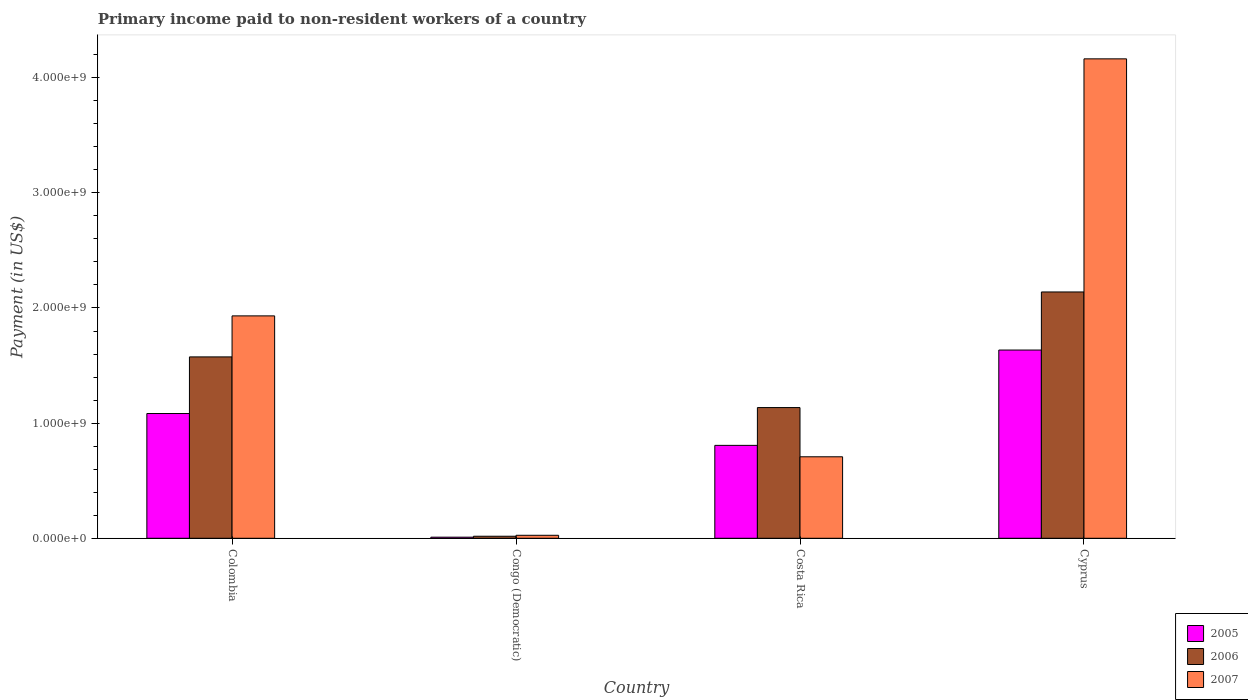How many different coloured bars are there?
Offer a very short reply. 3. How many groups of bars are there?
Provide a short and direct response. 4. How many bars are there on the 2nd tick from the left?
Offer a terse response. 3. How many bars are there on the 4th tick from the right?
Keep it short and to the point. 3. What is the amount paid to workers in 2005 in Costa Rica?
Provide a short and direct response. 8.07e+08. Across all countries, what is the maximum amount paid to workers in 2005?
Make the answer very short. 1.63e+09. Across all countries, what is the minimum amount paid to workers in 2006?
Give a very brief answer. 1.77e+07. In which country was the amount paid to workers in 2006 maximum?
Give a very brief answer. Cyprus. In which country was the amount paid to workers in 2007 minimum?
Your answer should be compact. Congo (Democratic). What is the total amount paid to workers in 2007 in the graph?
Provide a short and direct response. 6.83e+09. What is the difference between the amount paid to workers in 2006 in Colombia and that in Congo (Democratic)?
Your answer should be very brief. 1.56e+09. What is the difference between the amount paid to workers in 2007 in Congo (Democratic) and the amount paid to workers in 2005 in Costa Rica?
Your answer should be very brief. -7.81e+08. What is the average amount paid to workers in 2007 per country?
Make the answer very short. 1.71e+09. What is the difference between the amount paid to workers of/in 2006 and amount paid to workers of/in 2005 in Cyprus?
Your response must be concise. 5.04e+08. What is the ratio of the amount paid to workers in 2006 in Colombia to that in Costa Rica?
Your response must be concise. 1.39. What is the difference between the highest and the second highest amount paid to workers in 2005?
Your answer should be compact. -8.28e+08. What is the difference between the highest and the lowest amount paid to workers in 2005?
Give a very brief answer. 1.63e+09. How many countries are there in the graph?
Ensure brevity in your answer.  4. What is the difference between two consecutive major ticks on the Y-axis?
Offer a terse response. 1.00e+09. Does the graph contain grids?
Give a very brief answer. No. Where does the legend appear in the graph?
Your response must be concise. Bottom right. What is the title of the graph?
Your answer should be very brief. Primary income paid to non-resident workers of a country. What is the label or title of the Y-axis?
Provide a succinct answer. Payment (in US$). What is the Payment (in US$) of 2005 in Colombia?
Provide a succinct answer. 1.08e+09. What is the Payment (in US$) in 2006 in Colombia?
Provide a short and direct response. 1.58e+09. What is the Payment (in US$) of 2007 in Colombia?
Provide a succinct answer. 1.93e+09. What is the Payment (in US$) in 2005 in Congo (Democratic)?
Give a very brief answer. 9.50e+06. What is the Payment (in US$) in 2006 in Congo (Democratic)?
Offer a very short reply. 1.77e+07. What is the Payment (in US$) in 2007 in Congo (Democratic)?
Keep it short and to the point. 2.60e+07. What is the Payment (in US$) in 2005 in Costa Rica?
Ensure brevity in your answer.  8.07e+08. What is the Payment (in US$) in 2006 in Costa Rica?
Offer a terse response. 1.14e+09. What is the Payment (in US$) of 2007 in Costa Rica?
Give a very brief answer. 7.08e+08. What is the Payment (in US$) in 2005 in Cyprus?
Provide a short and direct response. 1.63e+09. What is the Payment (in US$) in 2006 in Cyprus?
Your answer should be compact. 2.14e+09. What is the Payment (in US$) in 2007 in Cyprus?
Your response must be concise. 4.16e+09. Across all countries, what is the maximum Payment (in US$) of 2005?
Make the answer very short. 1.63e+09. Across all countries, what is the maximum Payment (in US$) of 2006?
Ensure brevity in your answer.  2.14e+09. Across all countries, what is the maximum Payment (in US$) of 2007?
Your answer should be very brief. 4.16e+09. Across all countries, what is the minimum Payment (in US$) of 2005?
Give a very brief answer. 9.50e+06. Across all countries, what is the minimum Payment (in US$) of 2006?
Make the answer very short. 1.77e+07. Across all countries, what is the minimum Payment (in US$) in 2007?
Offer a very short reply. 2.60e+07. What is the total Payment (in US$) of 2005 in the graph?
Your response must be concise. 3.53e+09. What is the total Payment (in US$) of 2006 in the graph?
Provide a succinct answer. 4.87e+09. What is the total Payment (in US$) of 2007 in the graph?
Offer a very short reply. 6.83e+09. What is the difference between the Payment (in US$) of 2005 in Colombia and that in Congo (Democratic)?
Provide a succinct answer. 1.07e+09. What is the difference between the Payment (in US$) of 2006 in Colombia and that in Congo (Democratic)?
Your answer should be very brief. 1.56e+09. What is the difference between the Payment (in US$) of 2007 in Colombia and that in Congo (Democratic)?
Keep it short and to the point. 1.91e+09. What is the difference between the Payment (in US$) of 2005 in Colombia and that in Costa Rica?
Your answer should be compact. 2.77e+08. What is the difference between the Payment (in US$) in 2006 in Colombia and that in Costa Rica?
Your answer should be compact. 4.40e+08. What is the difference between the Payment (in US$) in 2007 in Colombia and that in Costa Rica?
Your answer should be compact. 1.22e+09. What is the difference between the Payment (in US$) of 2005 in Colombia and that in Cyprus?
Give a very brief answer. -5.51e+08. What is the difference between the Payment (in US$) of 2006 in Colombia and that in Cyprus?
Offer a terse response. -5.64e+08. What is the difference between the Payment (in US$) in 2007 in Colombia and that in Cyprus?
Your answer should be compact. -2.23e+09. What is the difference between the Payment (in US$) of 2005 in Congo (Democratic) and that in Costa Rica?
Your answer should be very brief. -7.97e+08. What is the difference between the Payment (in US$) of 2006 in Congo (Democratic) and that in Costa Rica?
Make the answer very short. -1.12e+09. What is the difference between the Payment (in US$) in 2007 in Congo (Democratic) and that in Costa Rica?
Provide a short and direct response. -6.82e+08. What is the difference between the Payment (in US$) in 2005 in Congo (Democratic) and that in Cyprus?
Ensure brevity in your answer.  -1.63e+09. What is the difference between the Payment (in US$) of 2006 in Congo (Democratic) and that in Cyprus?
Provide a succinct answer. -2.12e+09. What is the difference between the Payment (in US$) in 2007 in Congo (Democratic) and that in Cyprus?
Make the answer very short. -4.14e+09. What is the difference between the Payment (in US$) of 2005 in Costa Rica and that in Cyprus?
Give a very brief answer. -8.28e+08. What is the difference between the Payment (in US$) in 2006 in Costa Rica and that in Cyprus?
Provide a succinct answer. -1.00e+09. What is the difference between the Payment (in US$) in 2007 in Costa Rica and that in Cyprus?
Provide a succinct answer. -3.46e+09. What is the difference between the Payment (in US$) of 2005 in Colombia and the Payment (in US$) of 2006 in Congo (Democratic)?
Your answer should be compact. 1.07e+09. What is the difference between the Payment (in US$) in 2005 in Colombia and the Payment (in US$) in 2007 in Congo (Democratic)?
Provide a succinct answer. 1.06e+09. What is the difference between the Payment (in US$) in 2006 in Colombia and the Payment (in US$) in 2007 in Congo (Democratic)?
Ensure brevity in your answer.  1.55e+09. What is the difference between the Payment (in US$) in 2005 in Colombia and the Payment (in US$) in 2006 in Costa Rica?
Your answer should be very brief. -5.16e+07. What is the difference between the Payment (in US$) of 2005 in Colombia and the Payment (in US$) of 2007 in Costa Rica?
Provide a succinct answer. 3.76e+08. What is the difference between the Payment (in US$) of 2006 in Colombia and the Payment (in US$) of 2007 in Costa Rica?
Give a very brief answer. 8.67e+08. What is the difference between the Payment (in US$) in 2005 in Colombia and the Payment (in US$) in 2006 in Cyprus?
Offer a terse response. -1.06e+09. What is the difference between the Payment (in US$) in 2005 in Colombia and the Payment (in US$) in 2007 in Cyprus?
Provide a succinct answer. -3.08e+09. What is the difference between the Payment (in US$) of 2006 in Colombia and the Payment (in US$) of 2007 in Cyprus?
Your answer should be compact. -2.59e+09. What is the difference between the Payment (in US$) of 2005 in Congo (Democratic) and the Payment (in US$) of 2006 in Costa Rica?
Keep it short and to the point. -1.13e+09. What is the difference between the Payment (in US$) in 2005 in Congo (Democratic) and the Payment (in US$) in 2007 in Costa Rica?
Your response must be concise. -6.98e+08. What is the difference between the Payment (in US$) in 2006 in Congo (Democratic) and the Payment (in US$) in 2007 in Costa Rica?
Offer a terse response. -6.90e+08. What is the difference between the Payment (in US$) of 2005 in Congo (Democratic) and the Payment (in US$) of 2006 in Cyprus?
Offer a very short reply. -2.13e+09. What is the difference between the Payment (in US$) of 2005 in Congo (Democratic) and the Payment (in US$) of 2007 in Cyprus?
Your response must be concise. -4.15e+09. What is the difference between the Payment (in US$) of 2006 in Congo (Democratic) and the Payment (in US$) of 2007 in Cyprus?
Keep it short and to the point. -4.15e+09. What is the difference between the Payment (in US$) in 2005 in Costa Rica and the Payment (in US$) in 2006 in Cyprus?
Your response must be concise. -1.33e+09. What is the difference between the Payment (in US$) of 2005 in Costa Rica and the Payment (in US$) of 2007 in Cyprus?
Your response must be concise. -3.36e+09. What is the difference between the Payment (in US$) of 2006 in Costa Rica and the Payment (in US$) of 2007 in Cyprus?
Your answer should be compact. -3.03e+09. What is the average Payment (in US$) in 2005 per country?
Ensure brevity in your answer.  8.84e+08. What is the average Payment (in US$) in 2006 per country?
Offer a terse response. 1.22e+09. What is the average Payment (in US$) in 2007 per country?
Your answer should be compact. 1.71e+09. What is the difference between the Payment (in US$) in 2005 and Payment (in US$) in 2006 in Colombia?
Your answer should be compact. -4.92e+08. What is the difference between the Payment (in US$) in 2005 and Payment (in US$) in 2007 in Colombia?
Ensure brevity in your answer.  -8.48e+08. What is the difference between the Payment (in US$) of 2006 and Payment (in US$) of 2007 in Colombia?
Ensure brevity in your answer.  -3.56e+08. What is the difference between the Payment (in US$) in 2005 and Payment (in US$) in 2006 in Congo (Democratic)?
Your answer should be very brief. -8.20e+06. What is the difference between the Payment (in US$) of 2005 and Payment (in US$) of 2007 in Congo (Democratic)?
Keep it short and to the point. -1.65e+07. What is the difference between the Payment (in US$) in 2006 and Payment (in US$) in 2007 in Congo (Democratic)?
Your answer should be very brief. -8.30e+06. What is the difference between the Payment (in US$) in 2005 and Payment (in US$) in 2006 in Costa Rica?
Your answer should be compact. -3.28e+08. What is the difference between the Payment (in US$) in 2005 and Payment (in US$) in 2007 in Costa Rica?
Give a very brief answer. 9.92e+07. What is the difference between the Payment (in US$) of 2006 and Payment (in US$) of 2007 in Costa Rica?
Provide a succinct answer. 4.27e+08. What is the difference between the Payment (in US$) in 2005 and Payment (in US$) in 2006 in Cyprus?
Your response must be concise. -5.04e+08. What is the difference between the Payment (in US$) of 2005 and Payment (in US$) of 2007 in Cyprus?
Your response must be concise. -2.53e+09. What is the difference between the Payment (in US$) of 2006 and Payment (in US$) of 2007 in Cyprus?
Provide a succinct answer. -2.02e+09. What is the ratio of the Payment (in US$) in 2005 in Colombia to that in Congo (Democratic)?
Offer a very short reply. 114.05. What is the ratio of the Payment (in US$) of 2006 in Colombia to that in Congo (Democratic)?
Your answer should be compact. 88.99. What is the ratio of the Payment (in US$) of 2007 in Colombia to that in Congo (Democratic)?
Keep it short and to the point. 74.28. What is the ratio of the Payment (in US$) in 2005 in Colombia to that in Costa Rica?
Keep it short and to the point. 1.34. What is the ratio of the Payment (in US$) of 2006 in Colombia to that in Costa Rica?
Offer a terse response. 1.39. What is the ratio of the Payment (in US$) of 2007 in Colombia to that in Costa Rica?
Make the answer very short. 2.73. What is the ratio of the Payment (in US$) of 2005 in Colombia to that in Cyprus?
Offer a terse response. 0.66. What is the ratio of the Payment (in US$) of 2006 in Colombia to that in Cyprus?
Keep it short and to the point. 0.74. What is the ratio of the Payment (in US$) of 2007 in Colombia to that in Cyprus?
Ensure brevity in your answer.  0.46. What is the ratio of the Payment (in US$) of 2005 in Congo (Democratic) to that in Costa Rica?
Provide a succinct answer. 0.01. What is the ratio of the Payment (in US$) in 2006 in Congo (Democratic) to that in Costa Rica?
Provide a succinct answer. 0.02. What is the ratio of the Payment (in US$) of 2007 in Congo (Democratic) to that in Costa Rica?
Ensure brevity in your answer.  0.04. What is the ratio of the Payment (in US$) of 2005 in Congo (Democratic) to that in Cyprus?
Make the answer very short. 0.01. What is the ratio of the Payment (in US$) in 2006 in Congo (Democratic) to that in Cyprus?
Provide a succinct answer. 0.01. What is the ratio of the Payment (in US$) of 2007 in Congo (Democratic) to that in Cyprus?
Offer a terse response. 0.01. What is the ratio of the Payment (in US$) in 2005 in Costa Rica to that in Cyprus?
Ensure brevity in your answer.  0.49. What is the ratio of the Payment (in US$) of 2006 in Costa Rica to that in Cyprus?
Give a very brief answer. 0.53. What is the ratio of the Payment (in US$) in 2007 in Costa Rica to that in Cyprus?
Your response must be concise. 0.17. What is the difference between the highest and the second highest Payment (in US$) in 2005?
Offer a terse response. 5.51e+08. What is the difference between the highest and the second highest Payment (in US$) of 2006?
Your response must be concise. 5.64e+08. What is the difference between the highest and the second highest Payment (in US$) in 2007?
Your response must be concise. 2.23e+09. What is the difference between the highest and the lowest Payment (in US$) of 2005?
Offer a terse response. 1.63e+09. What is the difference between the highest and the lowest Payment (in US$) of 2006?
Make the answer very short. 2.12e+09. What is the difference between the highest and the lowest Payment (in US$) of 2007?
Provide a short and direct response. 4.14e+09. 